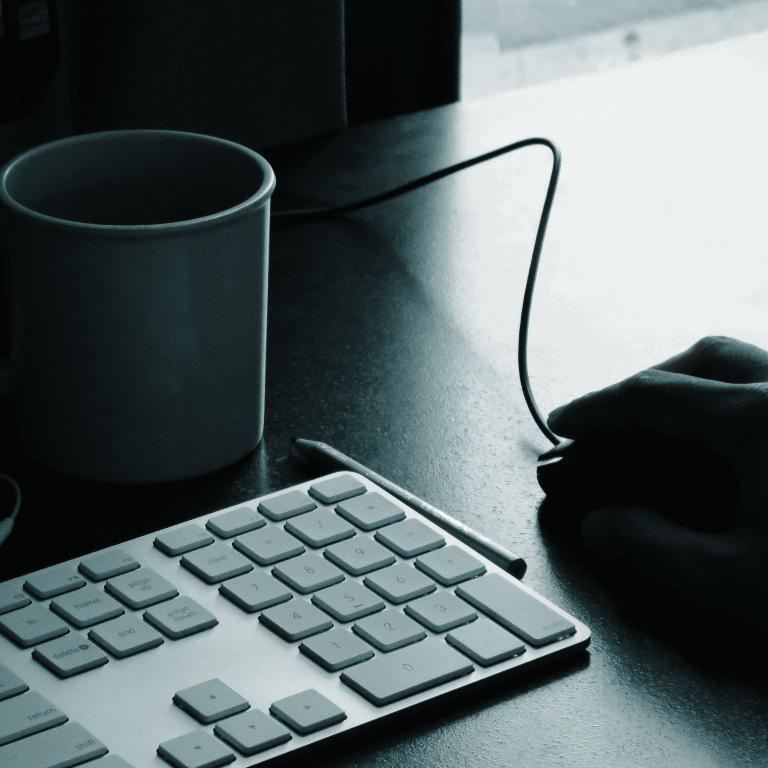Can you describe this image briefly? In this Image I see a person's hand on the mouse and I see a pencil, a keyboard and a cup. 